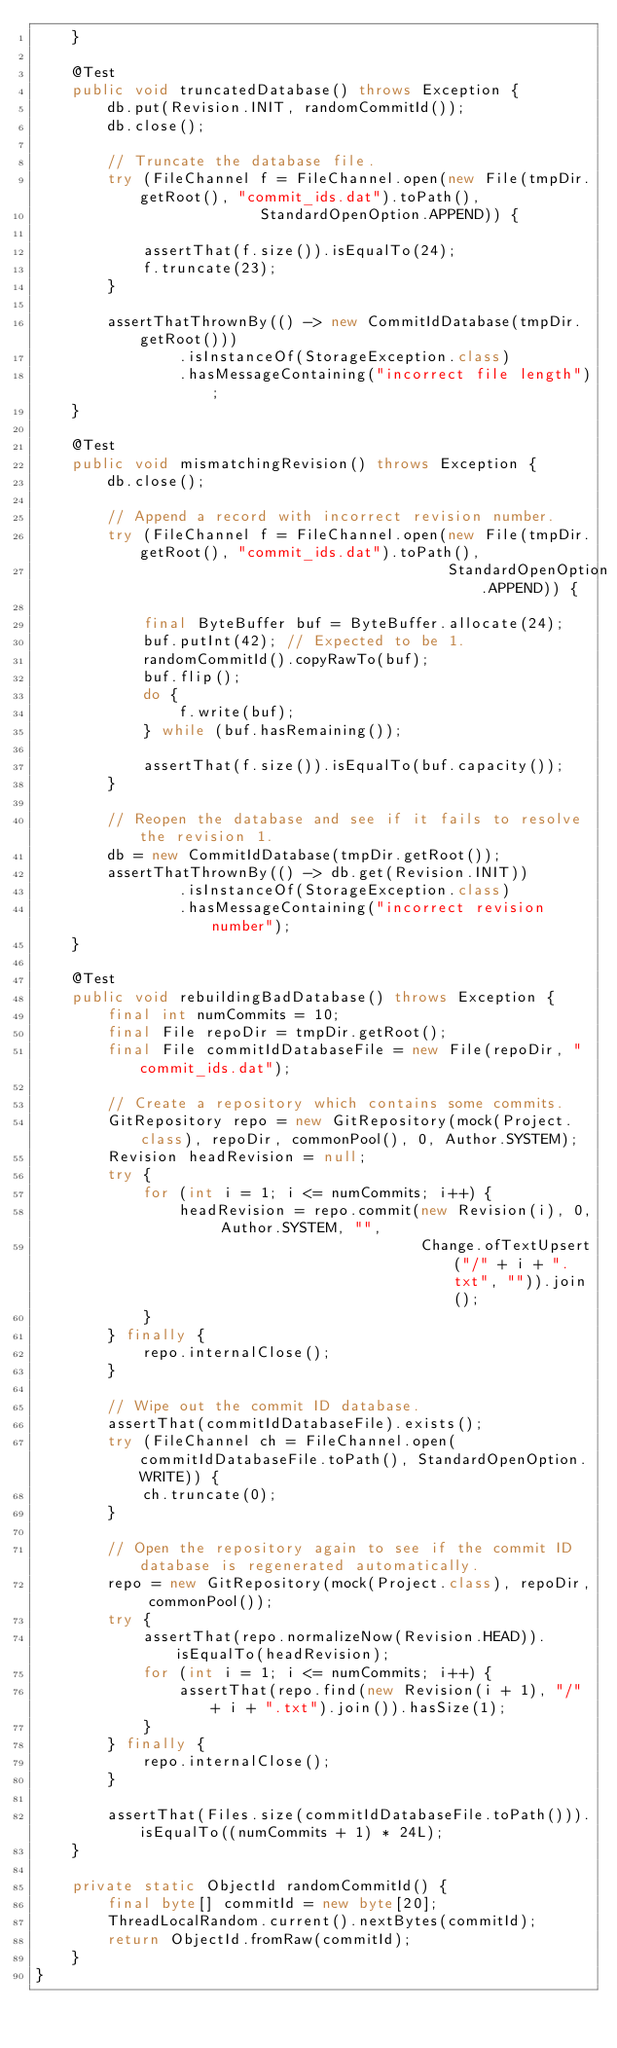Convert code to text. <code><loc_0><loc_0><loc_500><loc_500><_Java_>    }

    @Test
    public void truncatedDatabase() throws Exception {
        db.put(Revision.INIT, randomCommitId());
        db.close();

        // Truncate the database file.
        try (FileChannel f = FileChannel.open(new File(tmpDir.getRoot(), "commit_ids.dat").toPath(),
                         StandardOpenOption.APPEND)) {

            assertThat(f.size()).isEqualTo(24);
            f.truncate(23);
        }

        assertThatThrownBy(() -> new CommitIdDatabase(tmpDir.getRoot()))
                .isInstanceOf(StorageException.class)
                .hasMessageContaining("incorrect file length");
    }

    @Test
    public void mismatchingRevision() throws Exception {
        db.close();

        // Append a record with incorrect revision number.
        try (FileChannel f = FileChannel.open(new File(tmpDir.getRoot(), "commit_ids.dat").toPath(),
                                              StandardOpenOption.APPEND)) {

            final ByteBuffer buf = ByteBuffer.allocate(24);
            buf.putInt(42); // Expected to be 1.
            randomCommitId().copyRawTo(buf);
            buf.flip();
            do {
                f.write(buf);
            } while (buf.hasRemaining());

            assertThat(f.size()).isEqualTo(buf.capacity());
        }

        // Reopen the database and see if it fails to resolve the revision 1.
        db = new CommitIdDatabase(tmpDir.getRoot());
        assertThatThrownBy(() -> db.get(Revision.INIT))
                .isInstanceOf(StorageException.class)
                .hasMessageContaining("incorrect revision number");
    }

    @Test
    public void rebuildingBadDatabase() throws Exception {
        final int numCommits = 10;
        final File repoDir = tmpDir.getRoot();
        final File commitIdDatabaseFile = new File(repoDir, "commit_ids.dat");

        // Create a repository which contains some commits.
        GitRepository repo = new GitRepository(mock(Project.class), repoDir, commonPool(), 0, Author.SYSTEM);
        Revision headRevision = null;
        try {
            for (int i = 1; i <= numCommits; i++) {
                headRevision = repo.commit(new Revision(i), 0, Author.SYSTEM, "",
                                           Change.ofTextUpsert("/" + i + ".txt", "")).join();
            }
        } finally {
            repo.internalClose();
        }

        // Wipe out the commit ID database.
        assertThat(commitIdDatabaseFile).exists();
        try (FileChannel ch = FileChannel.open(commitIdDatabaseFile.toPath(), StandardOpenOption.WRITE)) {
            ch.truncate(0);
        }

        // Open the repository again to see if the commit ID database is regenerated automatically.
        repo = new GitRepository(mock(Project.class), repoDir, commonPool());
        try {
            assertThat(repo.normalizeNow(Revision.HEAD)).isEqualTo(headRevision);
            for (int i = 1; i <= numCommits; i++) {
                assertThat(repo.find(new Revision(i + 1), "/" + i + ".txt").join()).hasSize(1);
            }
        } finally {
            repo.internalClose();
        }

        assertThat(Files.size(commitIdDatabaseFile.toPath())).isEqualTo((numCommits + 1) * 24L);
    }

    private static ObjectId randomCommitId() {
        final byte[] commitId = new byte[20];
        ThreadLocalRandom.current().nextBytes(commitId);
        return ObjectId.fromRaw(commitId);
    }
}
</code> 